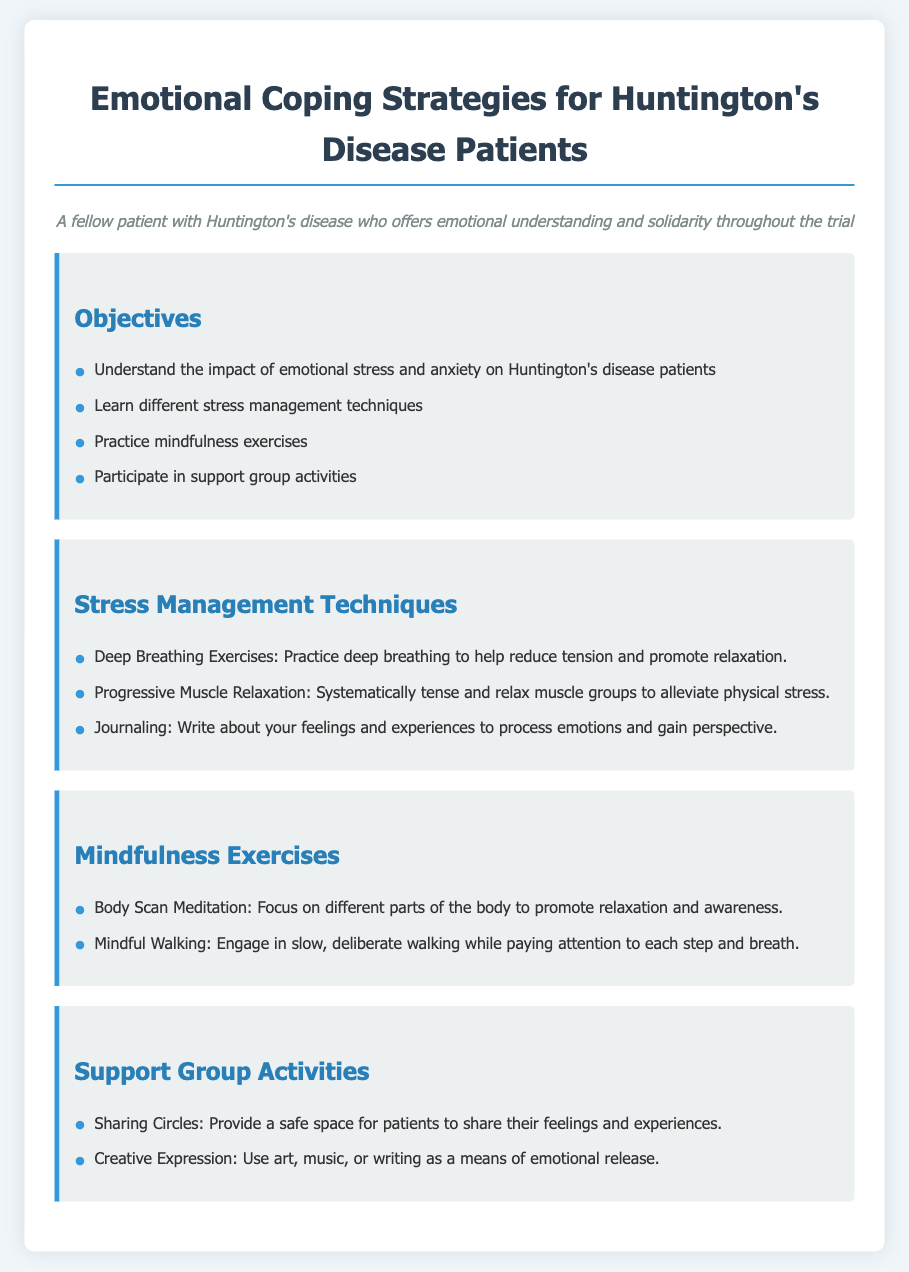what is the title of the lesson plan? The title is the primary heading of the document, which outlines the main focus of the content.
Answer: Emotional Coping Strategies for Huntington's Disease Patients how many stress management techniques are listed? The number of techniques is indicated by the items in the section titled "Stress Management Techniques."
Answer: 3 name one mindfulness exercise suggested in the lesson plan. The lesson plan lists specific mindfulness exercises, requiring identification of any mentioned exercise.
Answer: Body Scan Meditation what is one activity included in the support group section? The activities listed provide insight into the focus of support groups for patients, seeking a specific activity name.
Answer: Sharing Circles what is the color of the section headings? The color is a specific design element highlighted in the document that distinguishes the section headings from other text.
Answer: #2980b9 how many objectives are stated in the objectives section? The total number of objectives is found by counting the items listed in the "Objectives" section.
Answer: 4 which technique helps alleviate physical stress? This question requires recognition of a specific stress management technique mentioned in the document.
Answer: Progressive Muscle Relaxation what style is used for the persona description? The style of the persona description is indicated by its formatting and placement in the document.
Answer: Italic what does the background color of the body represent? The background color serves a specific design purpose that affects the visual aesthetic and readability of the document.
Answer: #f0f5f9 